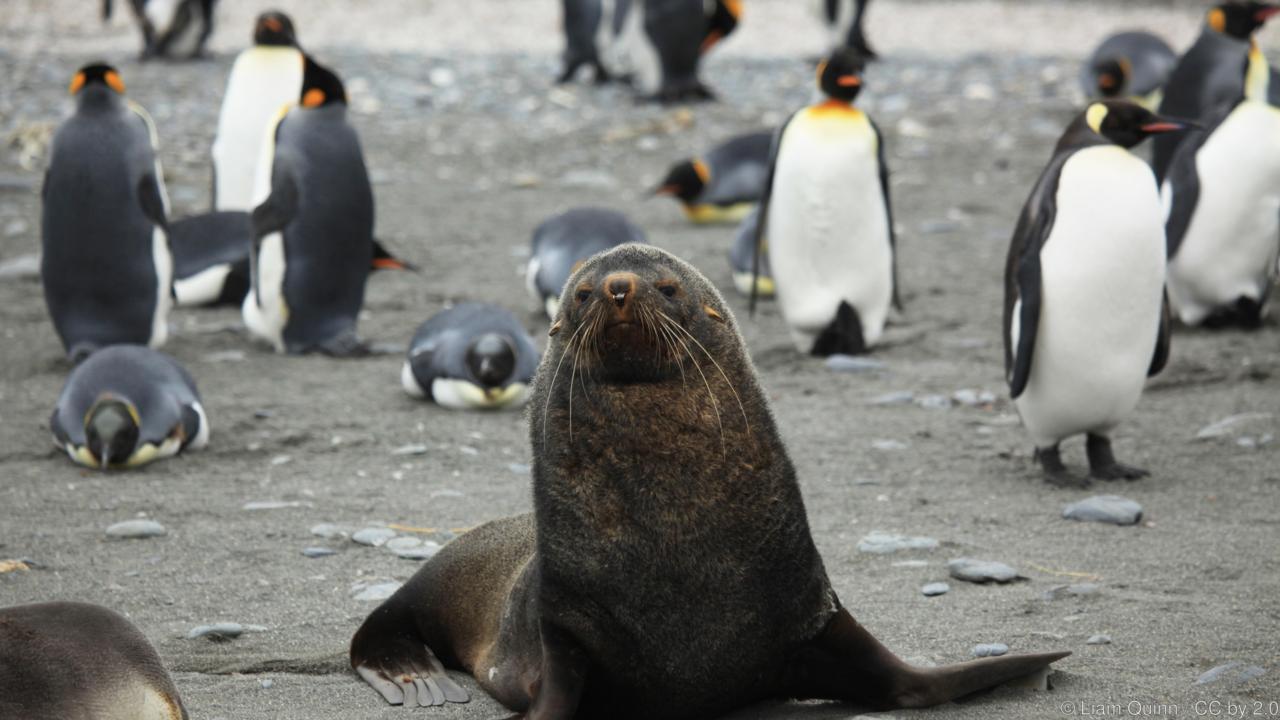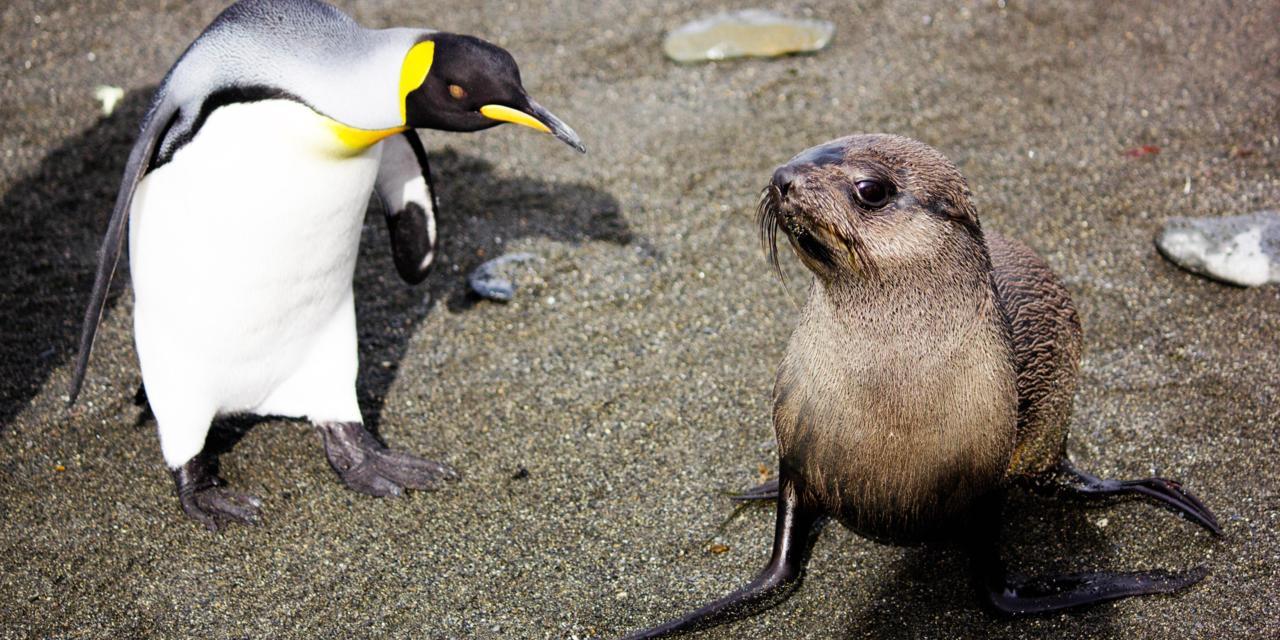The first image is the image on the left, the second image is the image on the right. Examine the images to the left and right. Is the description "There is a group of penguins standing near the water's edge with no bird in the forefront." accurate? Answer yes or no. No. 